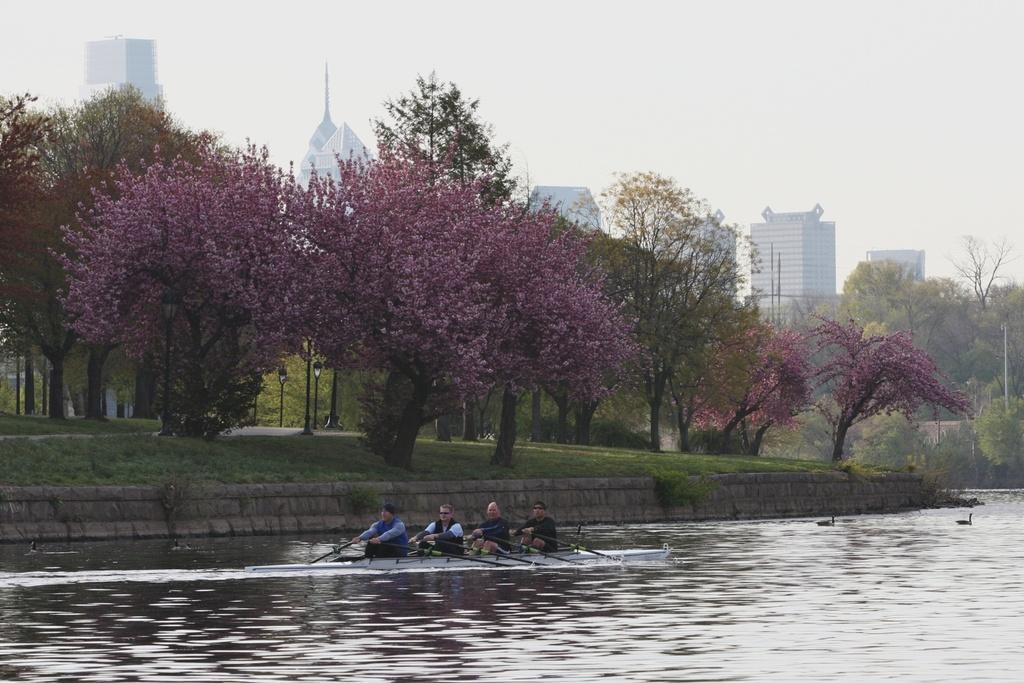Could you give a brief overview of what you see in this image? In this image I can see people riding a boat on the water. There are trees, light poles and buildings at the back. There is sky at the top. 